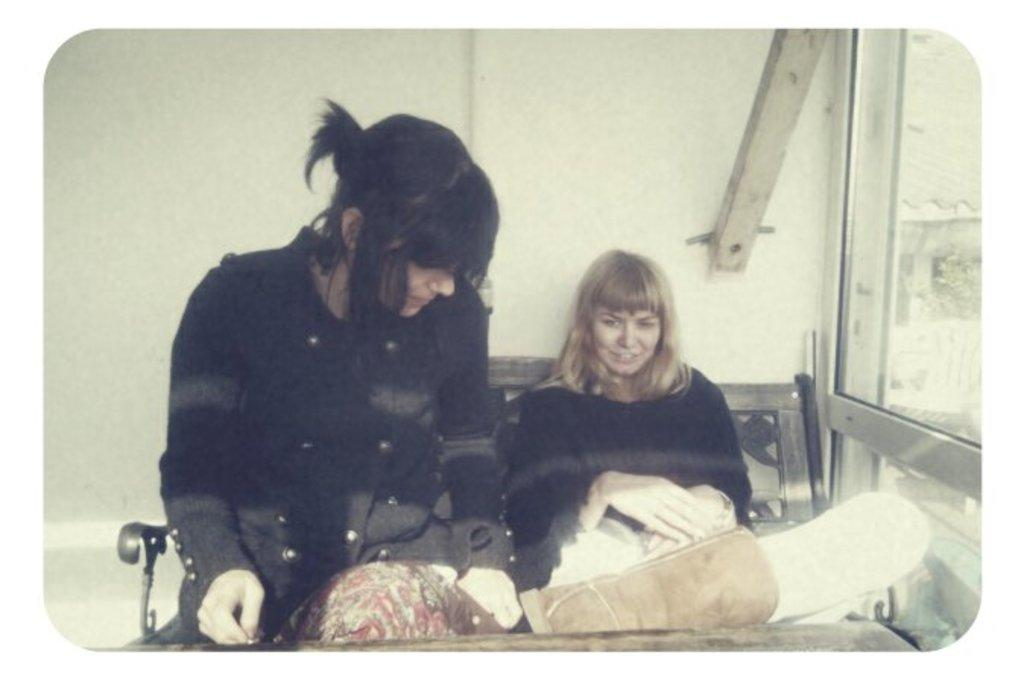How many people are sitting on the bench in the image? There are two ladies sitting on the bench in the image. What is in front of the bench? There is a table in front of the bench. What can be seen on the right side of the image? There is a door on the right side of the image. What is visible in the background of the image? There is a wall visible in the background of the image. What type of yard can be seen behind the wall in the image? There is no yard visible in the image; only a wall is present in the background. 